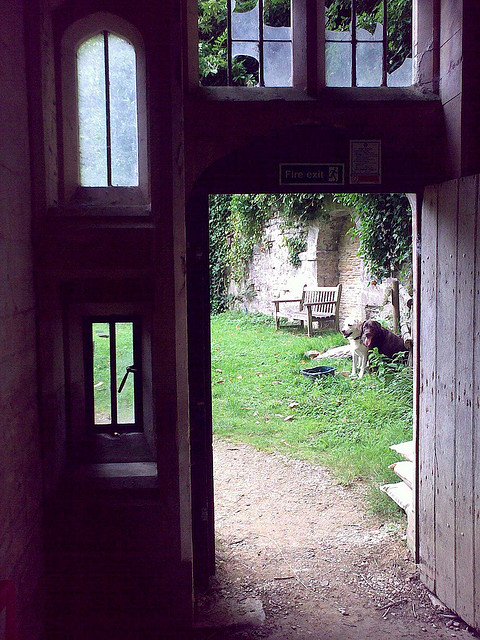<image>What kind of metal is beside the door? I can't tell what kind of metal is beside the door. It could be iron, steel, or none. What kind of metal is beside the door? I don't know what kind of metal is beside the door. It could be iron, steel, or something else. 